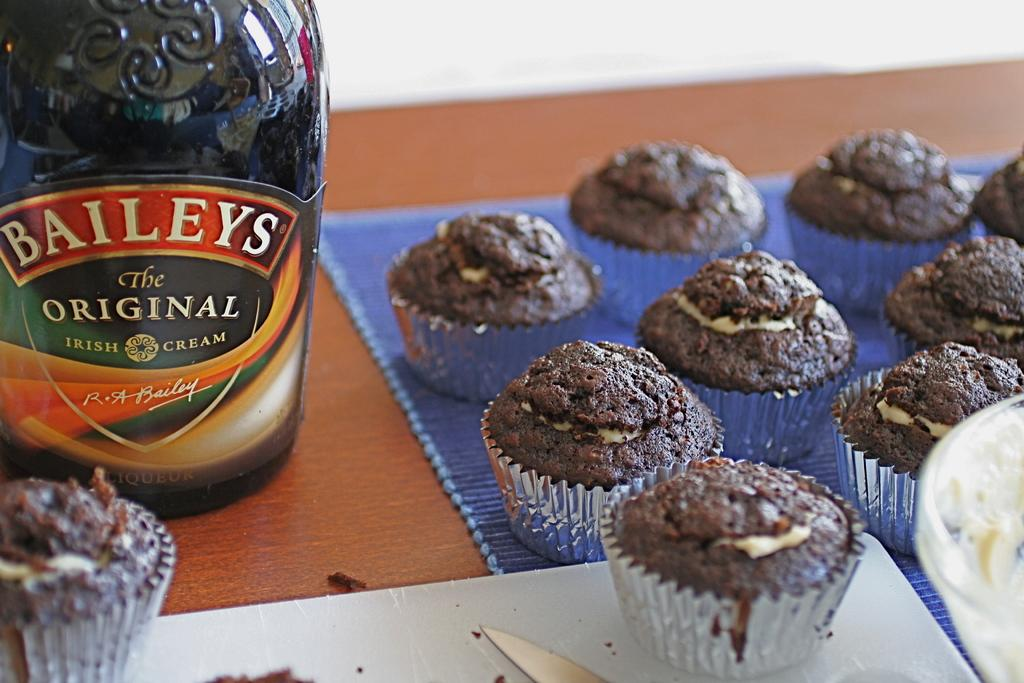What type of food is visible in the image? There are cupcakes in the image. What beverage is present in the image? There is a wine bottle in the image. What utensil can be seen in the image? There is a knife in the image. What container is present in the image? There is a bowl in the image. Where are all the objects located in the image? All objects are on a table. What type of plane is flying over the table in the image? There is no plane visible in the image; it only shows objects on a table. 